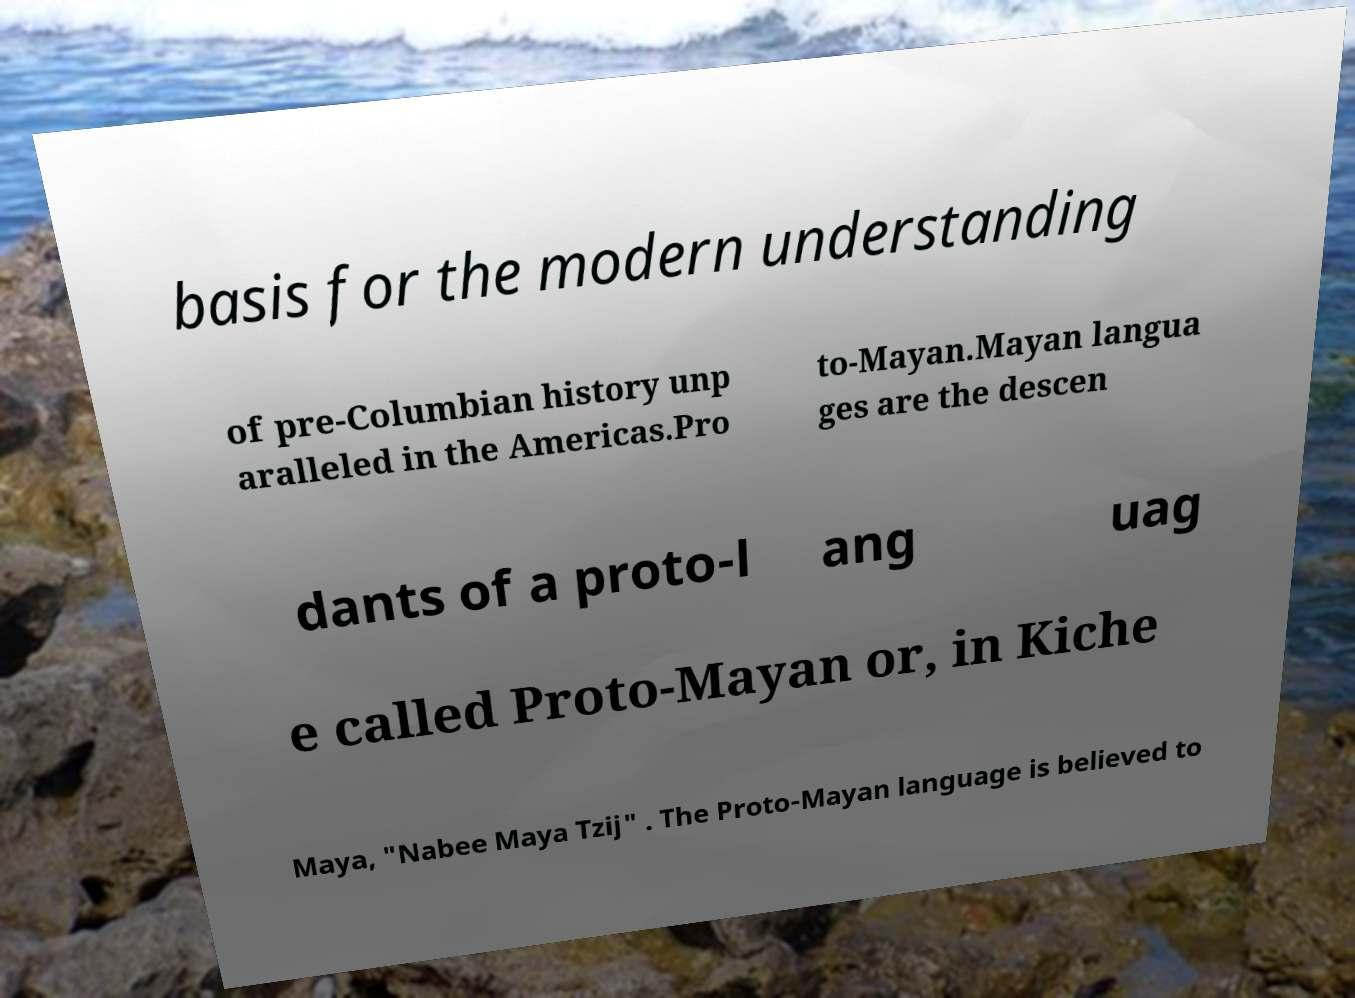Can you accurately transcribe the text from the provided image for me? basis for the modern understanding of pre-Columbian history unp aralleled in the Americas.Pro to-Mayan.Mayan langua ges are the descen dants of a proto-l ang uag e called Proto-Mayan or, in Kiche Maya, "Nabee Maya Tzij" . The Proto-Mayan language is believed to 